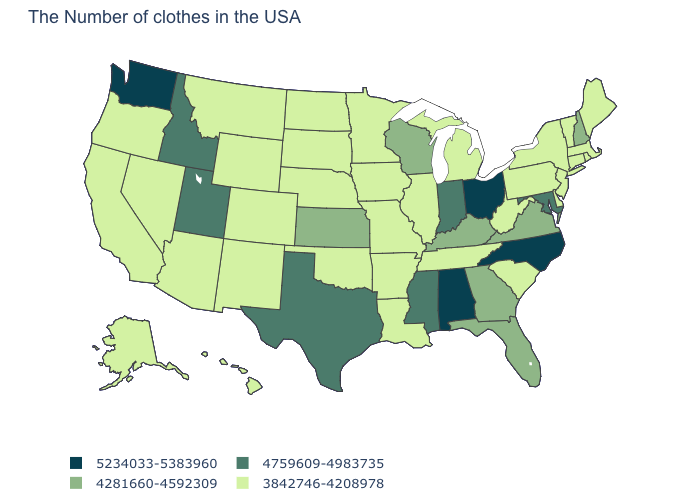Does North Carolina have the highest value in the USA?
Quick response, please. Yes. What is the value of South Dakota?
Short answer required. 3842746-4208978. What is the value of Kansas?
Short answer required. 4281660-4592309. Name the states that have a value in the range 4281660-4592309?
Write a very short answer. New Hampshire, Virginia, Florida, Georgia, Kentucky, Wisconsin, Kansas. How many symbols are there in the legend?
Short answer required. 4. Name the states that have a value in the range 3842746-4208978?
Answer briefly. Maine, Massachusetts, Rhode Island, Vermont, Connecticut, New York, New Jersey, Delaware, Pennsylvania, South Carolina, West Virginia, Michigan, Tennessee, Illinois, Louisiana, Missouri, Arkansas, Minnesota, Iowa, Nebraska, Oklahoma, South Dakota, North Dakota, Wyoming, Colorado, New Mexico, Montana, Arizona, Nevada, California, Oregon, Alaska, Hawaii. Does the first symbol in the legend represent the smallest category?
Quick response, please. No. Which states have the lowest value in the USA?
Be succinct. Maine, Massachusetts, Rhode Island, Vermont, Connecticut, New York, New Jersey, Delaware, Pennsylvania, South Carolina, West Virginia, Michigan, Tennessee, Illinois, Louisiana, Missouri, Arkansas, Minnesota, Iowa, Nebraska, Oklahoma, South Dakota, North Dakota, Wyoming, Colorado, New Mexico, Montana, Arizona, Nevada, California, Oregon, Alaska, Hawaii. What is the lowest value in the South?
Give a very brief answer. 3842746-4208978. What is the value of Virginia?
Give a very brief answer. 4281660-4592309. What is the highest value in the USA?
Concise answer only. 5234033-5383960. Among the states that border Rhode Island , which have the highest value?
Be succinct. Massachusetts, Connecticut. Which states have the lowest value in the Northeast?
Keep it brief. Maine, Massachusetts, Rhode Island, Vermont, Connecticut, New York, New Jersey, Pennsylvania. 